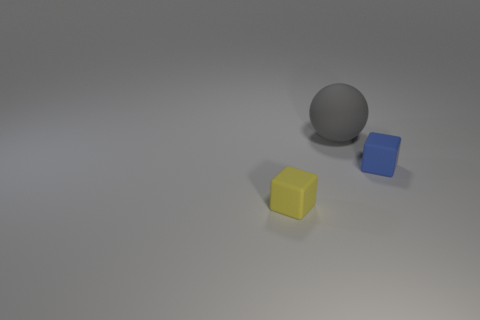There is a matte thing behind the rubber block to the right of the large gray rubber thing; what is its size?
Your answer should be compact. Large. What is the material of the yellow thing that is the same size as the blue cube?
Offer a very short reply. Rubber. Are there fewer yellow matte things behind the blue object than small rubber blocks that are behind the tiny yellow rubber object?
Offer a terse response. Yes. There is a thing in front of the small matte cube on the right side of the gray rubber object; what shape is it?
Offer a very short reply. Cube. Are any rubber spheres visible?
Provide a succinct answer. Yes. There is a matte thing that is on the right side of the rubber sphere; what color is it?
Your response must be concise. Blue. There is a ball; are there any small matte blocks on the right side of it?
Offer a terse response. Yes. Is the number of small blue rubber spheres greater than the number of big gray rubber balls?
Provide a succinct answer. No. What color is the small block that is on the right side of the small block left of the cube right of the large matte ball?
Provide a succinct answer. Blue. There is a sphere that is made of the same material as the tiny blue object; what is its color?
Offer a very short reply. Gray. 